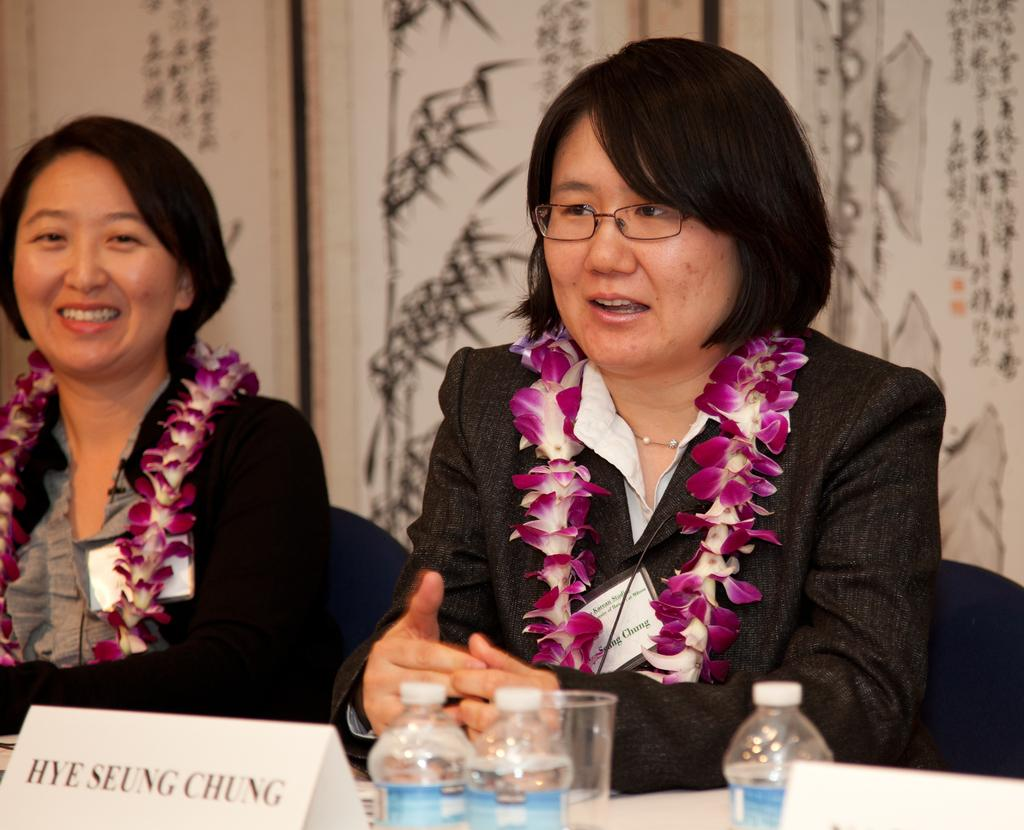What is present on the table in the image? There are bottles, glasses, and name boards on the table in the image. What objects are associated with the women sitting on chairs? The women are sitting on chairs, but there is no information about any objects associated with them. What can be seen in the background of the image? There is a wall in the background of the image. What type of bat is hanging from the ceiling in the image? There is no bat present in the image; it features a table with bottles, glasses, and name boards, as well as two women sitting on chairs and a wall in the background. 